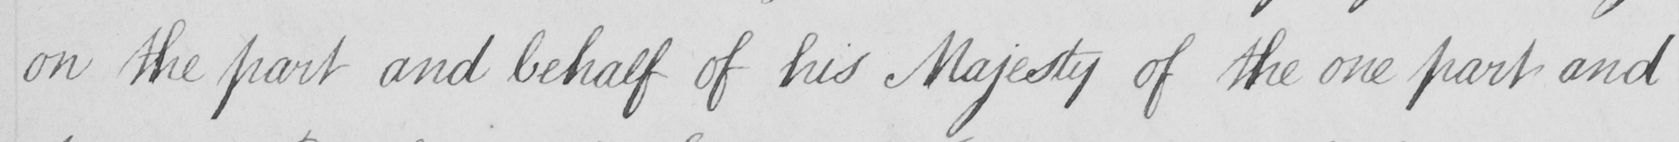Transcribe the text shown in this historical manuscript line. on the part and behalf of his Majesty of the one part and 